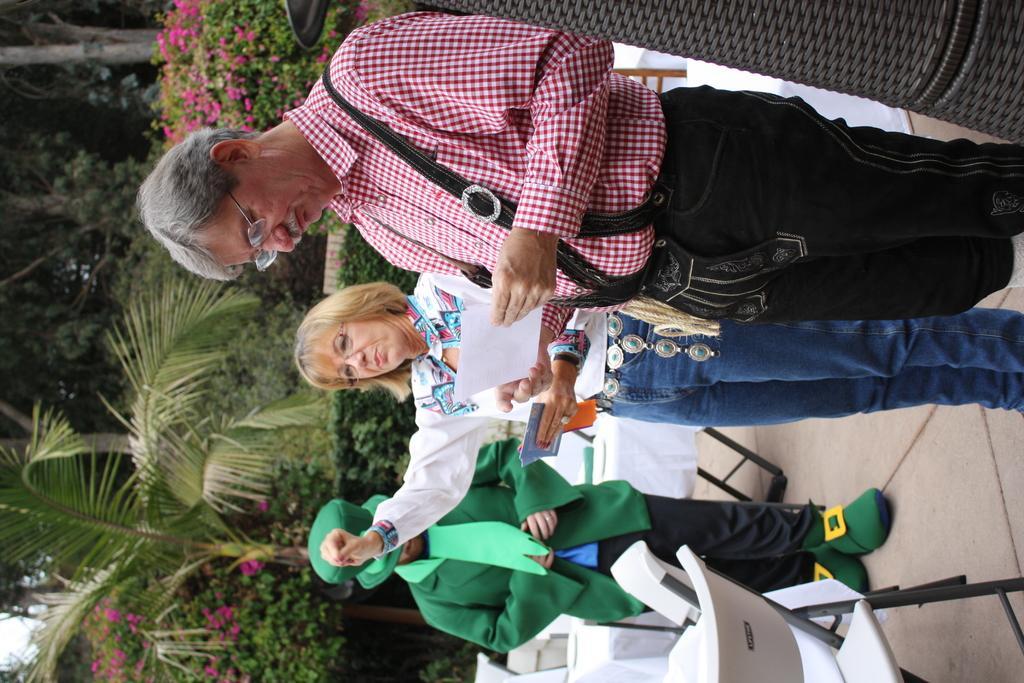Please provide a concise description of this image. In this image I can see three people are standing on the ground among them these two people are holding some objects in hands. In the background I can see trees, flower plants, chairs, tables and other objects on the ground. 